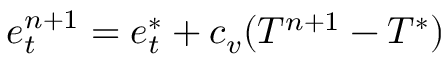Convert formula to latex. <formula><loc_0><loc_0><loc_500><loc_500>e _ { t } ^ { n + 1 } = e _ { t } ^ { * } + c _ { v } ( T ^ { n + 1 } - T ^ { * } )</formula> 